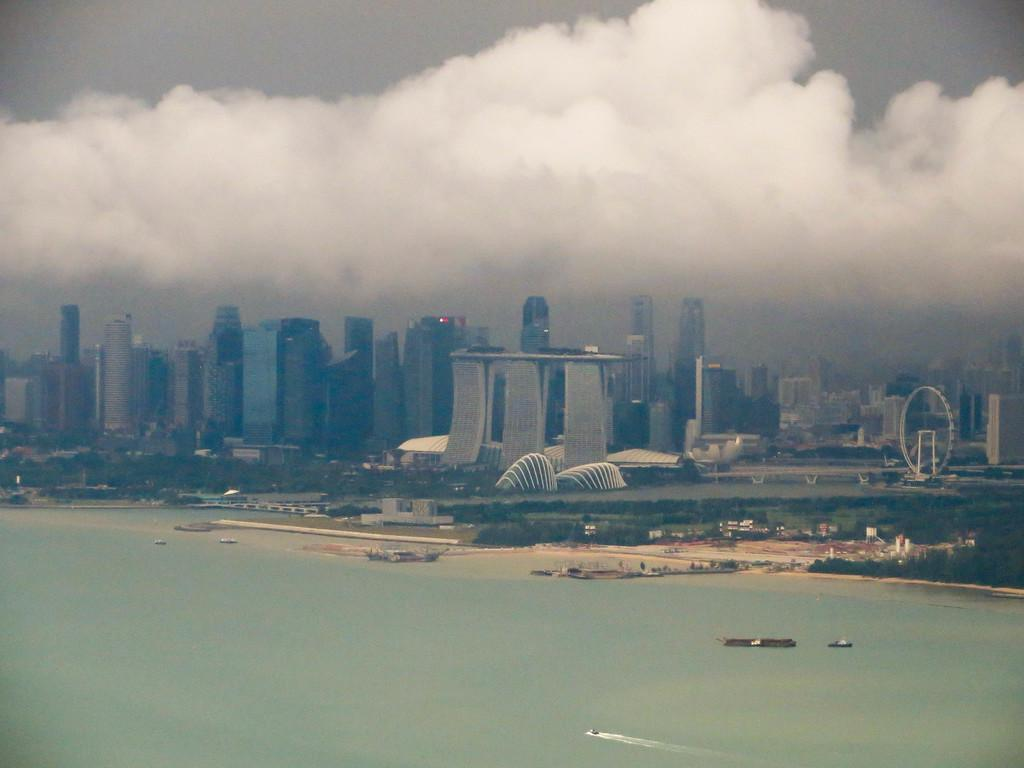What is present in the image that represents a natural element? There is water in the image, which represents a natural element. What else can be seen in the image that is related to nature? There are trees in the image. What structures are visible in the image? There are buildings in the image. What part of the environment is visible in the image? The sky is visible in the image. What is the condition of the sky in the image? The sky is cloudy in the image. How much money is being exchanged between the trees in the image? There is no money being exchanged in the image, as it features natural elements like water, trees, and buildings, along with a cloudy sky. 